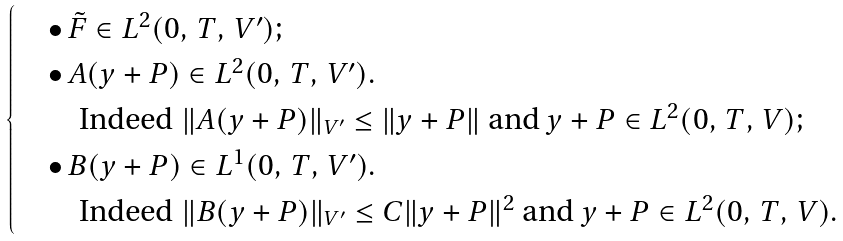<formula> <loc_0><loc_0><loc_500><loc_500>\begin{cases} & \bullet \, \tilde { F } \in L ^ { 2 } ( 0 , \, T , \, V ^ { \prime } ) ; \\ & \bullet \, A ( y + P ) \in L ^ { 2 } ( 0 , \, T , \, V ^ { \prime } ) . \\ & \quad \text {Indeed $\|A(y+P)\|_{V^{\prime}}\leq\|y+P\|$ and $y+P\in L^{2}(0,\,T,\,V)$} ; \\ & \bullet \, B ( y + P ) \in L ^ { 1 } ( 0 , \, T , \, V ^ { \prime } ) . \\ & \quad \text {Indeed $\|B(y+P)\|_{V^{\prime}}\leq C\|y+P\|^{2}$ and $y+P\in L^{2}(0,\,T,\,V)$} . \end{cases}</formula> 